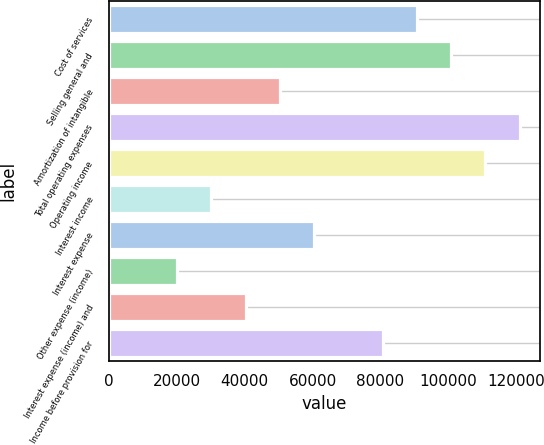<chart> <loc_0><loc_0><loc_500><loc_500><bar_chart><fcel>Cost of services<fcel>Selling general and<fcel>Amortization of intangible<fcel>Total operating expenses<fcel>Operating income<fcel>Interest income<fcel>Interest expense<fcel>Other expense (income)<fcel>Interest expense (income) and<fcel>Income before provision for<nl><fcel>90655.2<fcel>100728<fcel>50364.1<fcel>120874<fcel>110801<fcel>30218.5<fcel>60436.9<fcel>20145.7<fcel>40291.3<fcel>80582.4<nl></chart> 